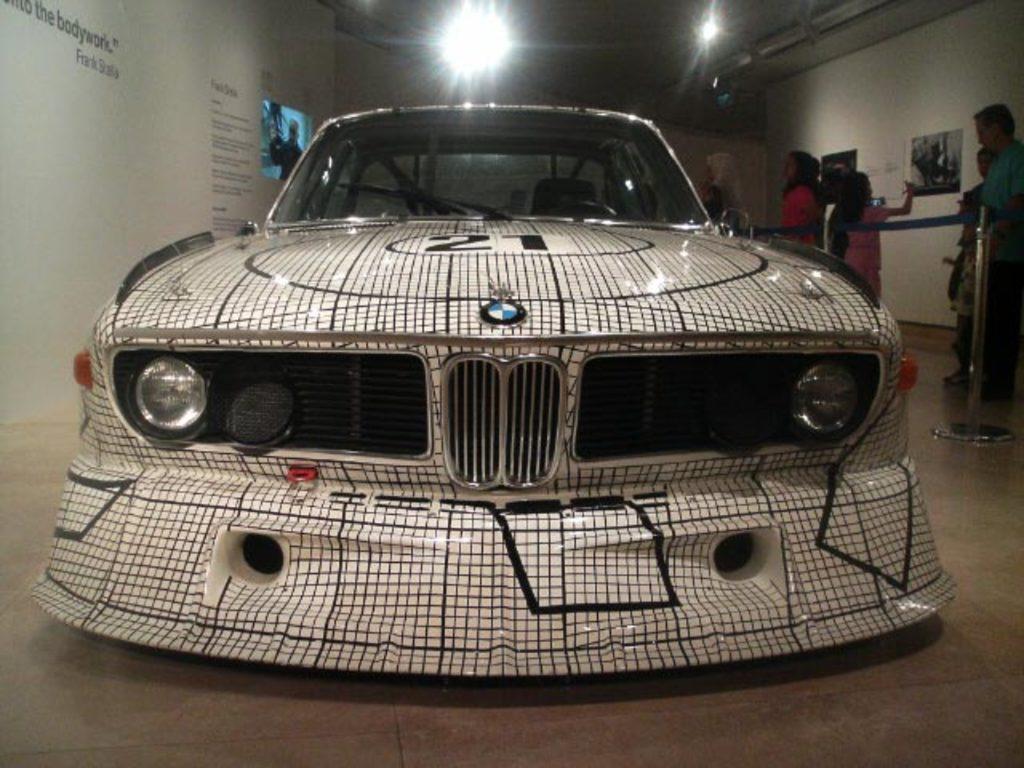Can you describe this image briefly? In this image we can see a car on the floor. Here we can see people, lights, and a stainless steel barrier. On the walls we can see posters and there is a screen. 